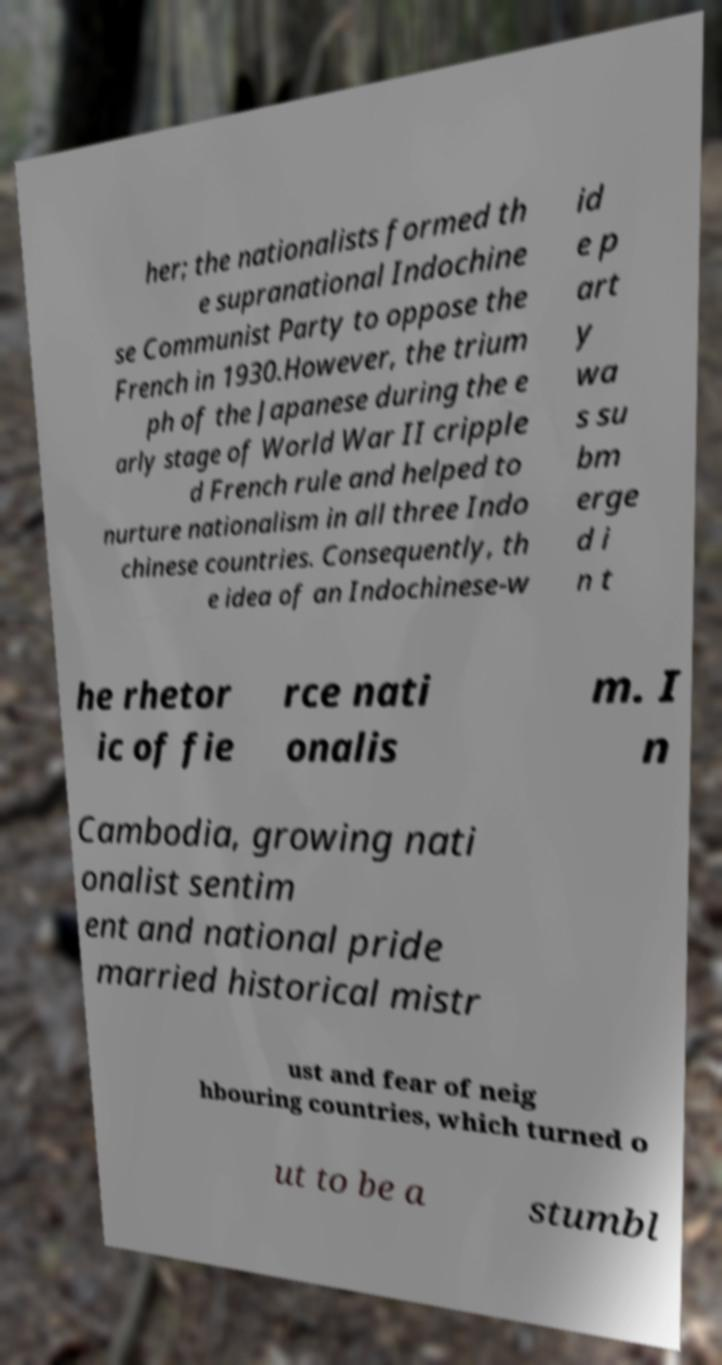Could you assist in decoding the text presented in this image and type it out clearly? her; the nationalists formed th e supranational Indochine se Communist Party to oppose the French in 1930.However, the trium ph of the Japanese during the e arly stage of World War II cripple d French rule and helped to nurture nationalism in all three Indo chinese countries. Consequently, th e idea of an Indochinese-w id e p art y wa s su bm erge d i n t he rhetor ic of fie rce nati onalis m. I n Cambodia, growing nati onalist sentim ent and national pride married historical mistr ust and fear of neig hbouring countries, which turned o ut to be a stumbl 